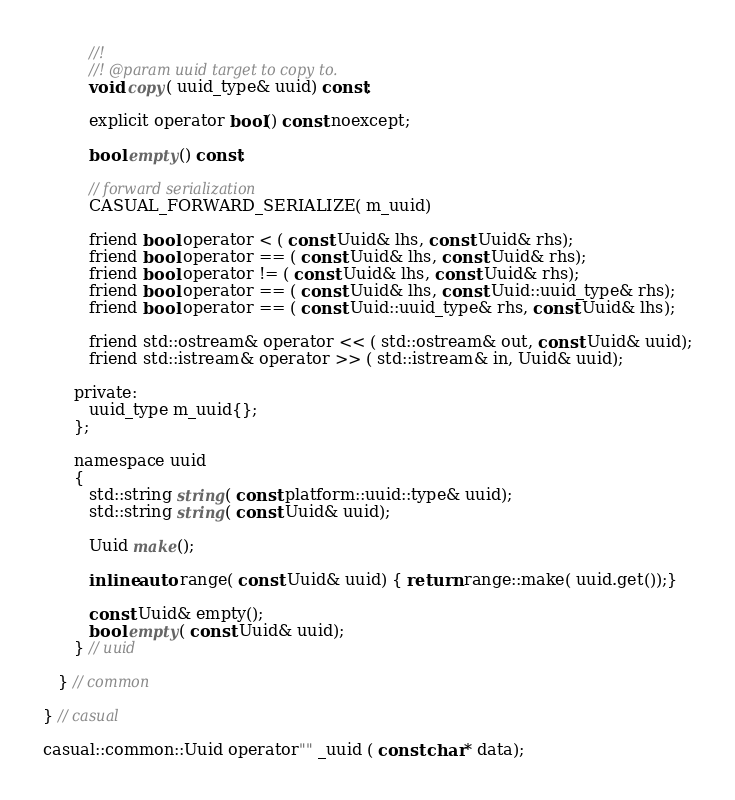Convert code to text. <code><loc_0><loc_0><loc_500><loc_500><_C_>         //!
         //! @param uuid target to copy to.
         void copy( uuid_type& uuid) const;

         explicit operator bool() const noexcept;

         bool empty() const;

         // forward serialization
         CASUAL_FORWARD_SERIALIZE( m_uuid)

         friend bool operator < ( const Uuid& lhs, const Uuid& rhs);
         friend bool operator == ( const Uuid& lhs, const Uuid& rhs);
         friend bool operator != ( const Uuid& lhs, const Uuid& rhs);
         friend bool operator == ( const Uuid& lhs, const Uuid::uuid_type& rhs);
         friend bool operator == ( const Uuid::uuid_type& rhs, const Uuid& lhs);

         friend std::ostream& operator << ( std::ostream& out, const Uuid& uuid);
         friend std::istream& operator >> ( std::istream& in, Uuid& uuid);

      private:
         uuid_type m_uuid{};
      };

      namespace uuid
      {
         std::string string( const platform::uuid::type& uuid);
         std::string string( const Uuid& uuid);

         Uuid make();

         inline auto range( const Uuid& uuid) { return range::make( uuid.get());}

         const Uuid& empty();
         bool empty( const Uuid& uuid);
      } // uuid

   } // common

} // casual

casual::common::Uuid operator"" _uuid ( const char* data);














</code> 